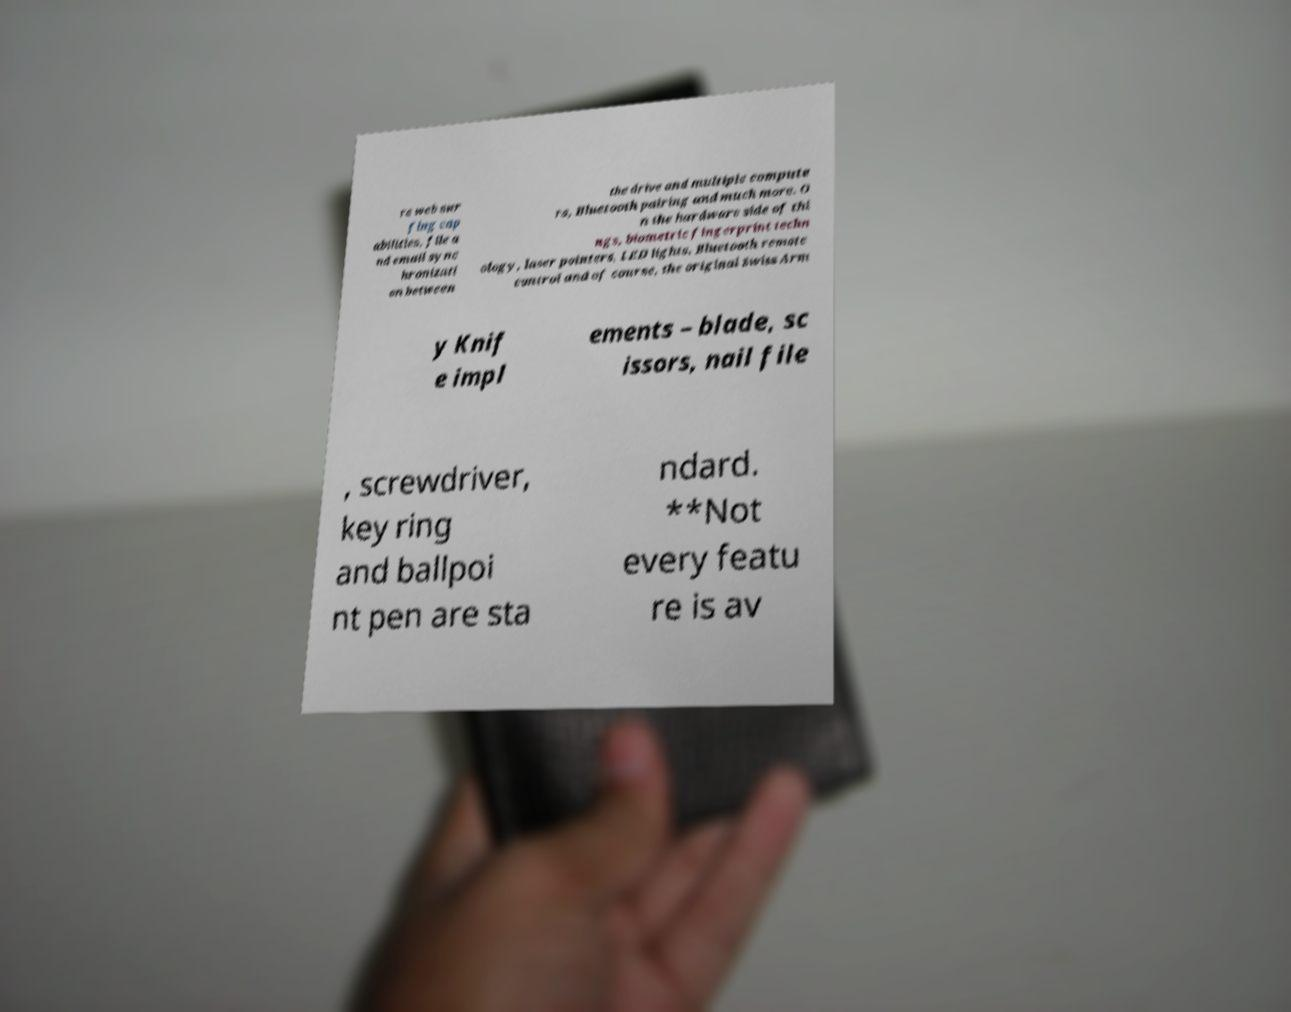What messages or text are displayed in this image? I need them in a readable, typed format. re web sur fing cap abilities, file a nd email sync hronizati on between the drive and multiple compute rs, Bluetooth pairing and much more. O n the hardware side of thi ngs, biometric fingerprint techn ology, laser pointers, LED lights, Bluetooth remote control and of course, the original Swiss Arm y Knif e impl ements – blade, sc issors, nail file , screwdriver, key ring and ballpoi nt pen are sta ndard. **Not every featu re is av 